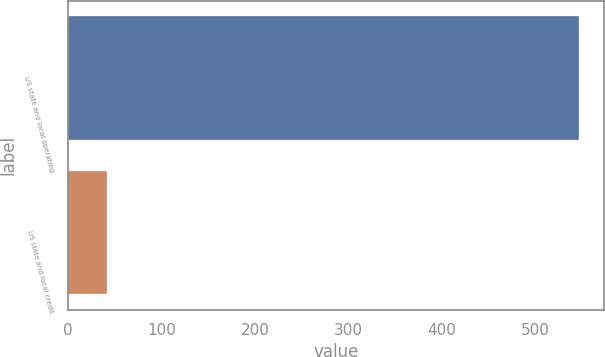<chart> <loc_0><loc_0><loc_500><loc_500><bar_chart><fcel>US state and local operating<fcel>US state and local credit<nl><fcel>546<fcel>42<nl></chart> 